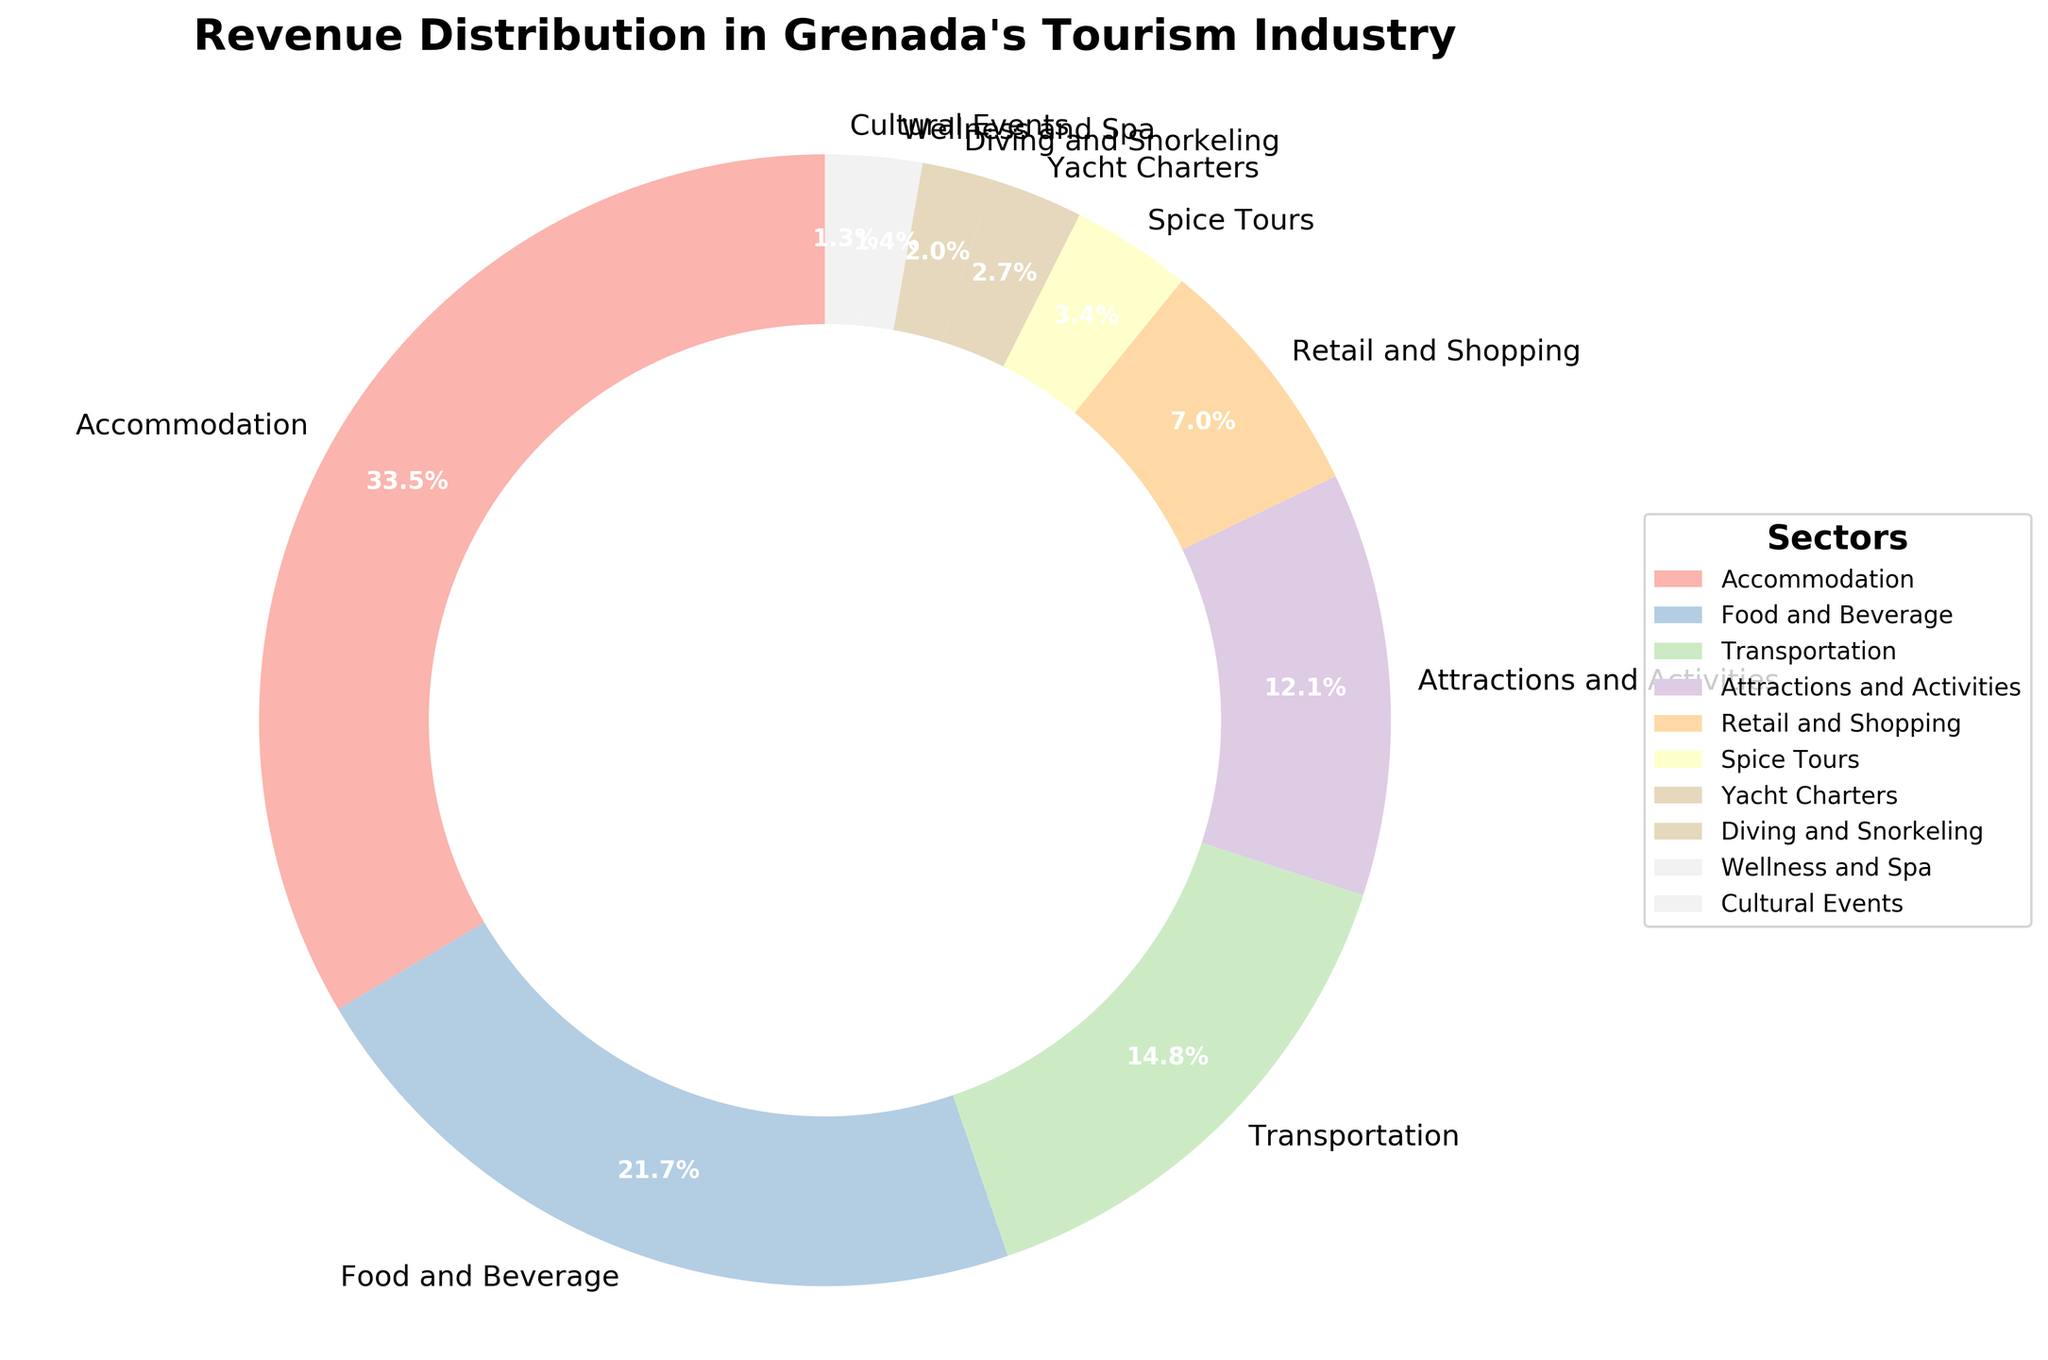Which sector has the highest revenue percentage? Looking at the pie chart, you can see that the sector with the largest slice is labeled "Accommodation".
Answer: Accommodation What is the combined revenue percentage of Food and Beverage and Retail and Shopping sectors? The revenue percentage for Food and Beverage is 22.8%, and for Retail and Shopping, it is 7.4%. Adding these together, 22.8 + 7.4 = 30.2%.
Answer: 30.2% Which sector has a higher revenue percentage, Wellness and Spa or Cultural Events? By observing the slices in the pie chart, the slice for Wellness and Spa is larger than that for Cultural Events. The percentages are 1.5% for Wellness and Spa and 1.4% for Cultural Events.
Answer: Wellness and Spa Which sector accounts for more revenue: Attractions and Activities or Transportation? The pie chart shows that the slice for Transportation (15.5%) is larger than the slice for Attractions and Activities (12.7%).
Answer: Transportation What is the total revenue percentage of all sectors with less than 5% revenue? The sectors under 5% are Spice Tours (3.6%), Yacht Charters (2.8%), Diving and Snorkeling (2.1%), Wellness and Spa (1.5%), and Cultural Events (1.4%). Adding these together: 3.6 + 2.8 + 2.1 + 1.5 + 1.4 = 11.4%.
Answer: 11.4% How much larger is the revenue percentage of Accommodation compared to Yacht Charters? The revenue percentage for Accommodation is 35.2% and for Yacht Charters it is 2.8%. Subtracting these, 35.2 - 2.8 = 32.4%.
Answer: 32.4% What is the average revenue percentage for the sectors Diving and Snorkeling, Wellness and Spa, and Cultural Events? The revenue percentages are Diving and Snorkeling (2.1%), Wellness and Spa (1.5%), and Cultural Events (1.4%). Adding these together: 2.1 + 1.5 + 1.4 = 5.0%, then dividing by the number of sectors (3), 5.0 / 3 ≈ 1.67%.
Answer: 1.67% Which sector whose revenue percentage is just above 3%? The sector with a revenue percentage just above 3% is Spice Tours, with a percentage of 3.6%.
Answer: Spice Tours What is the difference in revenue percentage between the largest and the smallest sector? The largest sector is Accommodation with 35.2%, and the smallest sector is Cultural Events with 1.4%. Subtracting these, 35.2 - 1.4 = 33.8%.
Answer: 33.8% How does the revenue percentage of Attractions and Activities compare to the combined revenue percentage of Diving and Snorkeling, Wellness and Spa, and Cultural Events? Combining the percentages of Diving and Snorkeling (2.1%), Wellness and Spa (1.5%), and Cultural Events (1.4%) gives us 2.1 + 1.5 + 1.4 = 5.0%. The percentage for Attractions and Activities is 12.7%, which is significantly higher than 5.0%.
Answer: Higher 